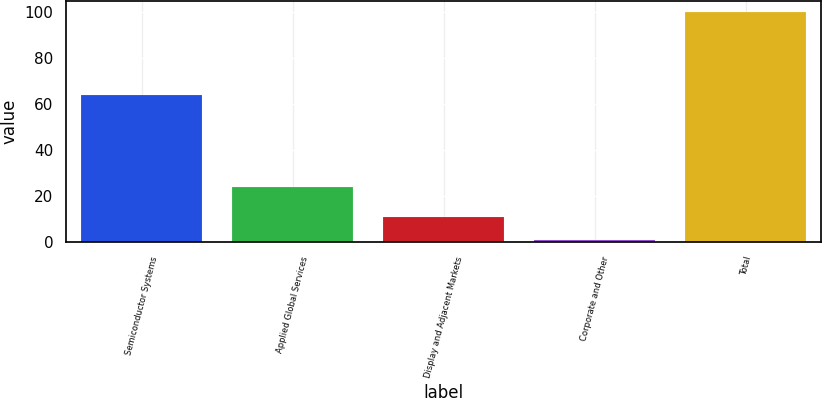<chart> <loc_0><loc_0><loc_500><loc_500><bar_chart><fcel>Semiconductor Systems<fcel>Applied Global Services<fcel>Display and Adjacent Markets<fcel>Corporate and Other<fcel>Total<nl><fcel>64<fcel>24<fcel>11<fcel>1<fcel>100<nl></chart> 